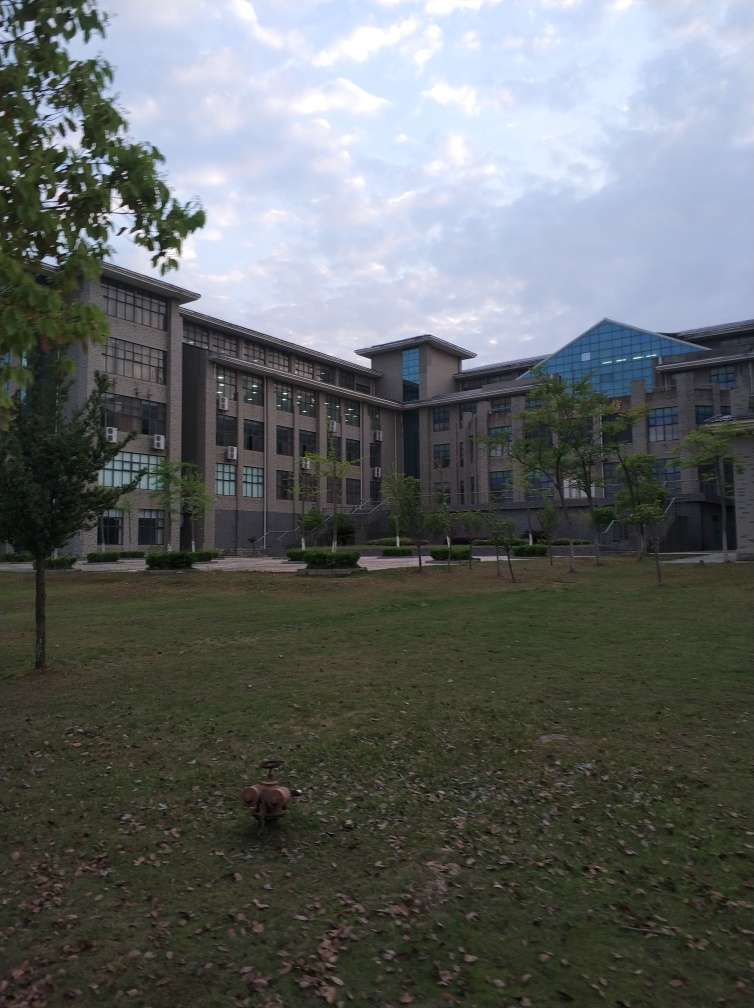Is there enough green space around the building? The image shows a considerable amount of greenery surrounding the building, including trees, grass, and what appears to be hedges or bushes near the structure. While not a dense forest, the green space provided seems sufficient for an urban setting, offering a touch of nature and contributing to the aesthetics of the area. 